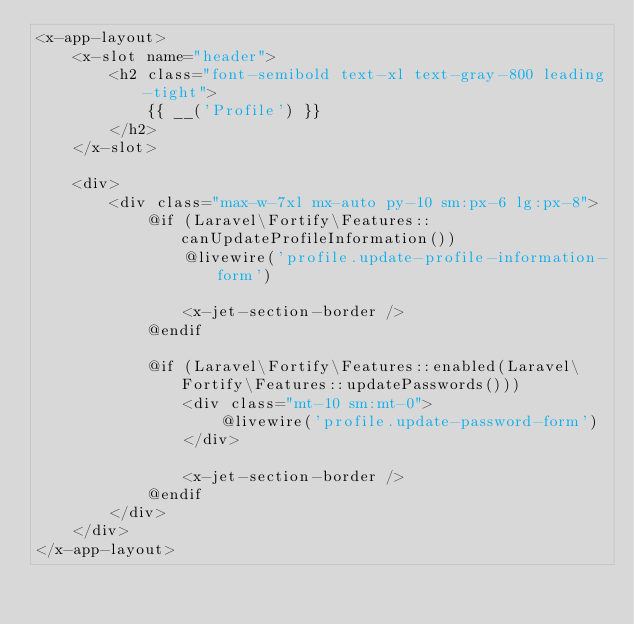<code> <loc_0><loc_0><loc_500><loc_500><_PHP_><x-app-layout>
    <x-slot name="header">
        <h2 class="font-semibold text-xl text-gray-800 leading-tight">
            {{ __('Profile') }}
        </h2>
    </x-slot>

    <div>
        <div class="max-w-7xl mx-auto py-10 sm:px-6 lg:px-8">
            @if (Laravel\Fortify\Features::canUpdateProfileInformation())
                @livewire('profile.update-profile-information-form')

                <x-jet-section-border />
            @endif

            @if (Laravel\Fortify\Features::enabled(Laravel\Fortify\Features::updatePasswords()))
                <div class="mt-10 sm:mt-0">
                    @livewire('profile.update-password-form')
                </div>

                <x-jet-section-border />
            @endif
        </div>
    </div>
</x-app-layout>
</code> 